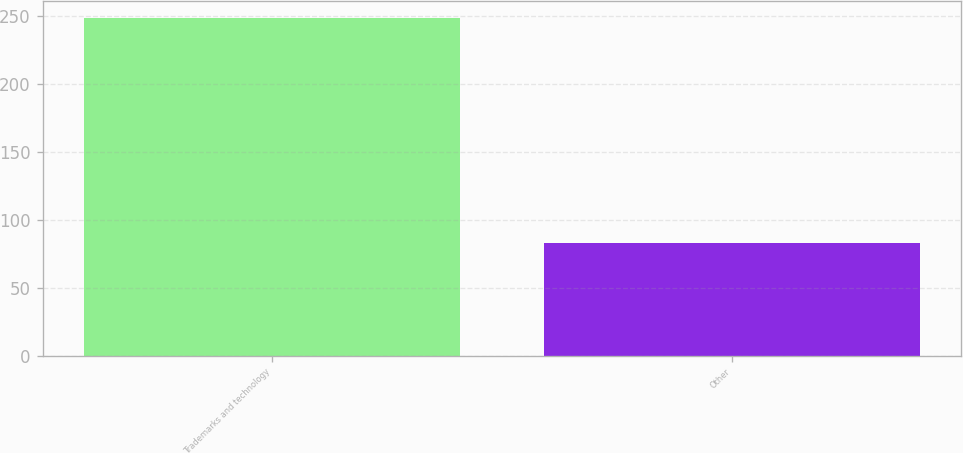Convert chart to OTSL. <chart><loc_0><loc_0><loc_500><loc_500><bar_chart><fcel>Trademarks and technology<fcel>Other<nl><fcel>249<fcel>83<nl></chart> 